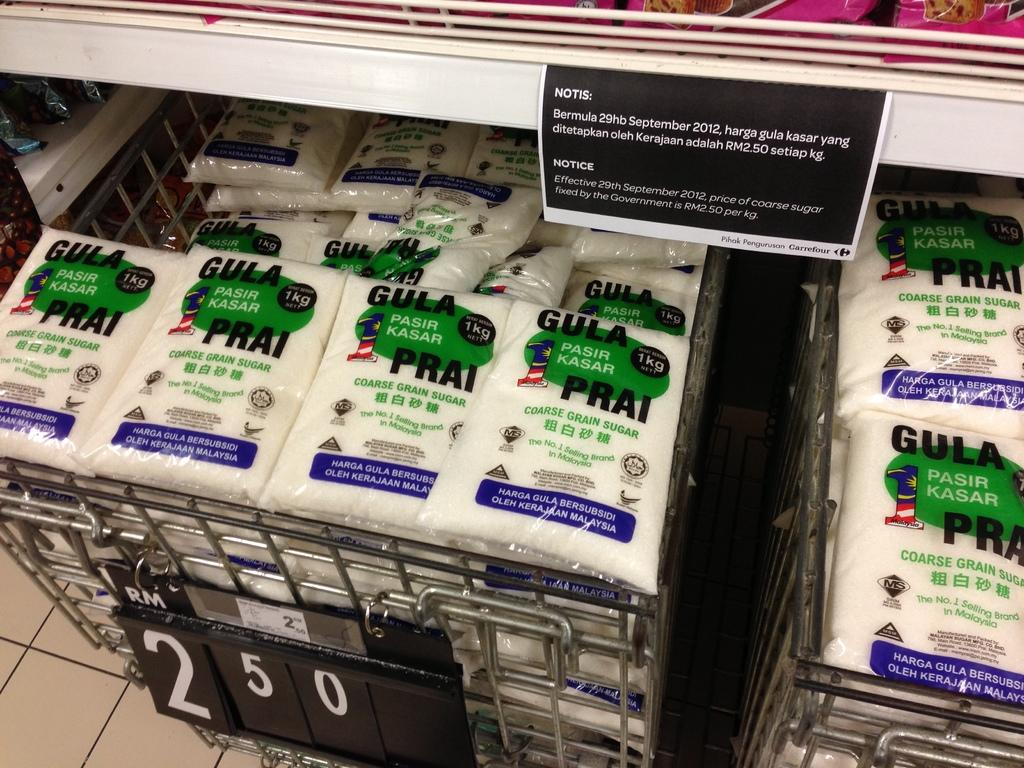<image>
Share a concise interpretation of the image provided. coarse grain sugar from Pasir Kasar in bins marked 2.50 